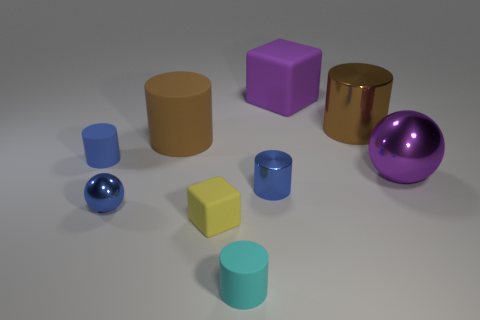Subtract all cyan cylinders. How many cylinders are left? 4 Add 1 cyan rubber cylinders. How many objects exist? 10 Subtract 1 balls. How many balls are left? 1 Subtract all purple balls. How many balls are left? 1 Subtract all green spheres. How many gray cylinders are left? 0 Subtract all blocks. How many objects are left? 7 Subtract all yellow spheres. Subtract all green cylinders. How many spheres are left? 2 Subtract all tiny purple rubber cylinders. Subtract all big matte cubes. How many objects are left? 8 Add 6 blue cylinders. How many blue cylinders are left? 8 Add 1 large brown objects. How many large brown objects exist? 3 